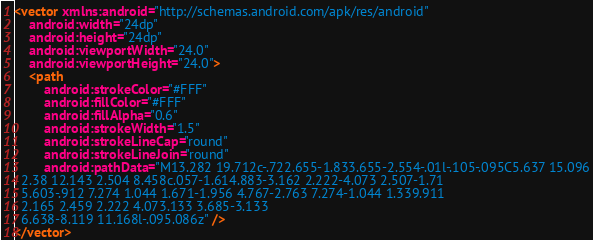<code> <loc_0><loc_0><loc_500><loc_500><_XML_><vector xmlns:android="http://schemas.android.com/apk/res/android"
    android:width="24dp"
    android:height="24dp"
    android:viewportWidth="24.0"
    android:viewportHeight="24.0">
    <path
        android:strokeColor="#FFF"
        android:fillColor="#FFF"
        android:fillAlpha="0.6"
        android:strokeWidth="1.5"
        android:strokeLineCap="round"
        android:strokeLineJoin="round"
        android:pathData="M13.282 19.712c-.722.655-1.833.655-2.554-.01l-.105-.095C5.637 15.096
  2.38 12.143 2.504 8.458c.057-1.614.883-3.162 2.222-4.073 2.507-1.71
  5.603-.912 7.274 1.044 1.671-1.956 4.767-2.763 7.274-1.044 1.339.911
  2.165 2.459 2.222 4.073.133 3.685-3.133
  6.638-8.119 11.168l-.095.086z" />
</vector></code> 